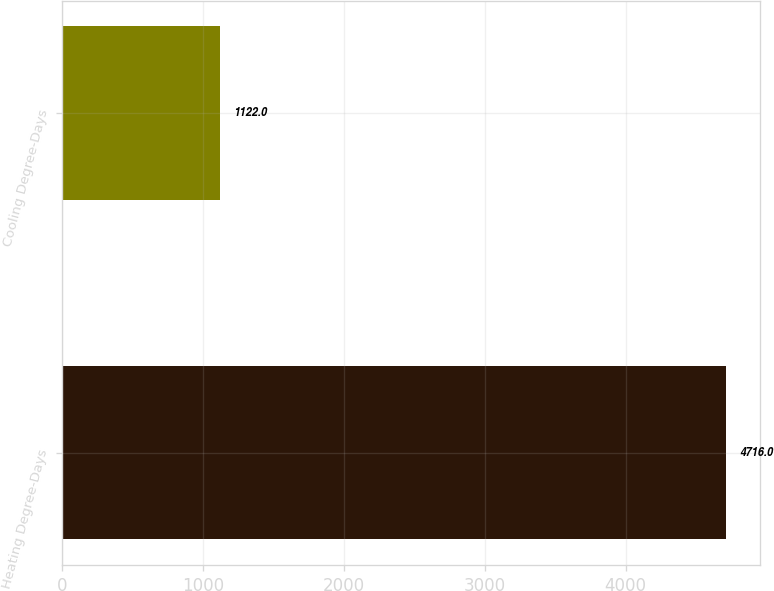<chart> <loc_0><loc_0><loc_500><loc_500><bar_chart><fcel>Heating Degree-Days<fcel>Cooling Degree-Days<nl><fcel>4716<fcel>1122<nl></chart> 